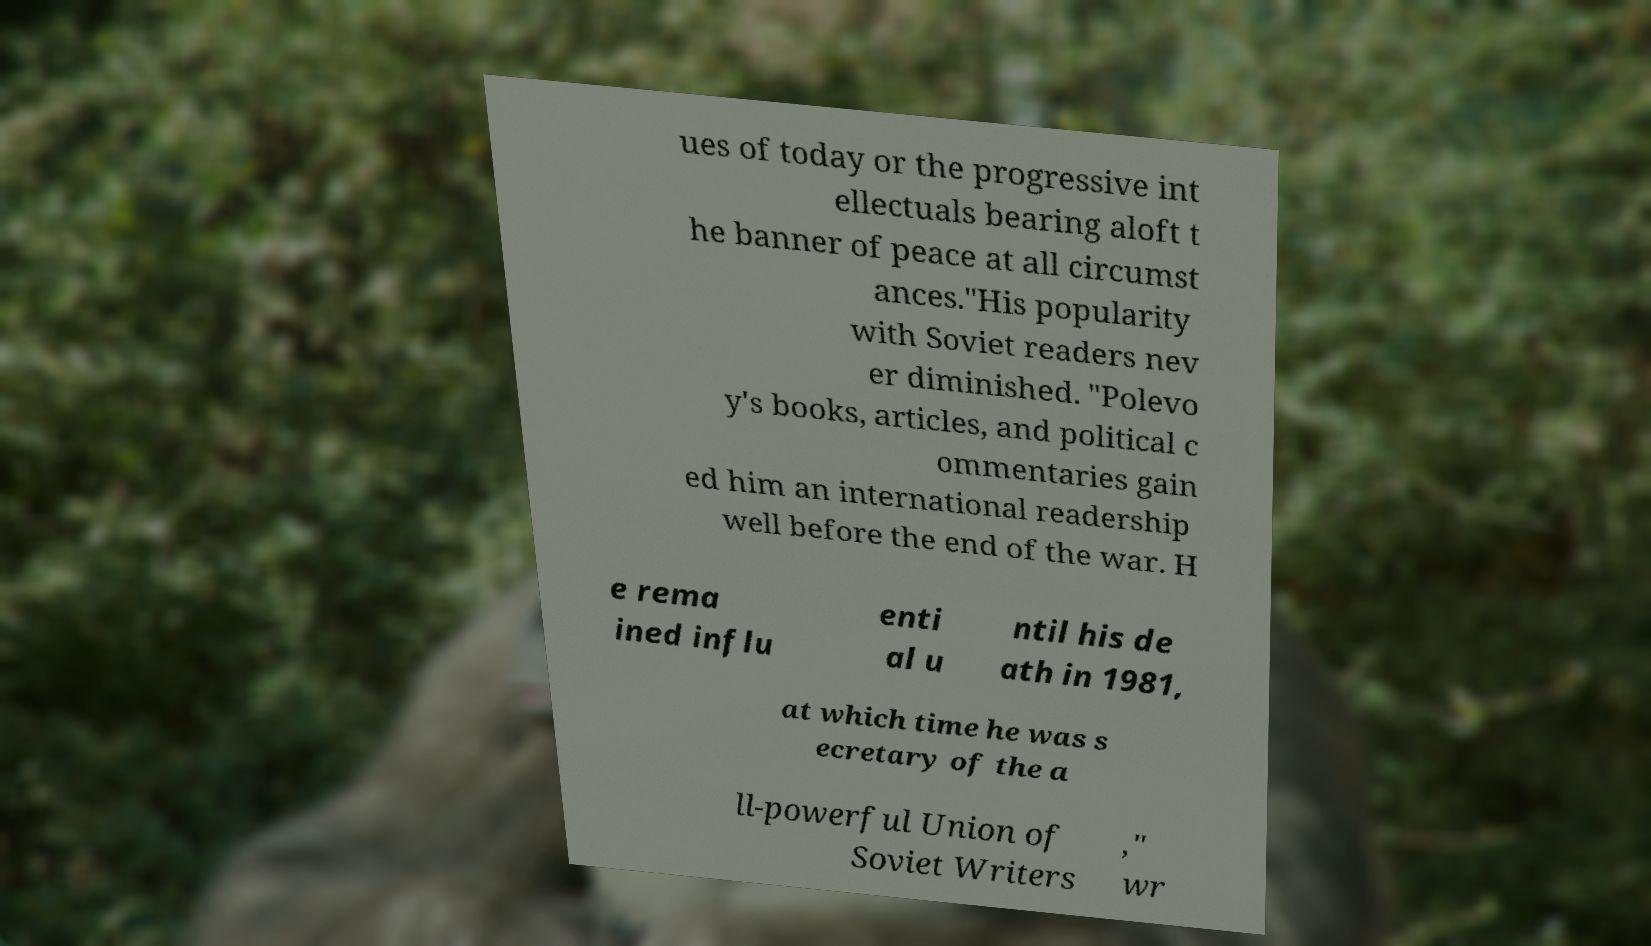I need the written content from this picture converted into text. Can you do that? ues of today or the progressive int ellectuals bearing aloft t he banner of peace at all circumst ances."His popularity with Soviet readers nev er diminished. "Polevo y's books, articles, and political c ommentaries gain ed him an international readership well before the end of the war. H e rema ined influ enti al u ntil his de ath in 1981, at which time he was s ecretary of the a ll-powerful Union of Soviet Writers ," wr 